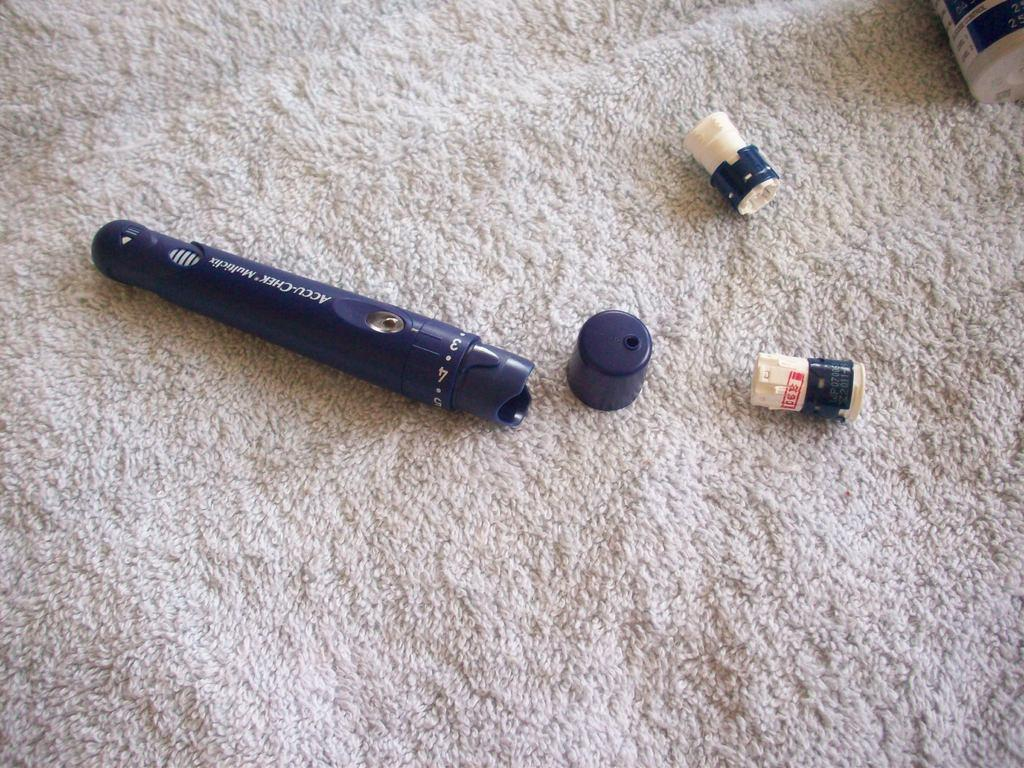What object in the image resembles a torch? There is an object in the image that resembles a torch. What is located at the bottom of the image? There is a cloth at the bottom of the image. How does the earthquake affect the hall in the image? There is no earthquake or hall present in the image; it only features an object resembling a torch and a cloth at the bottom. What type of rock can be seen in the image? There is no rock present in the image. 